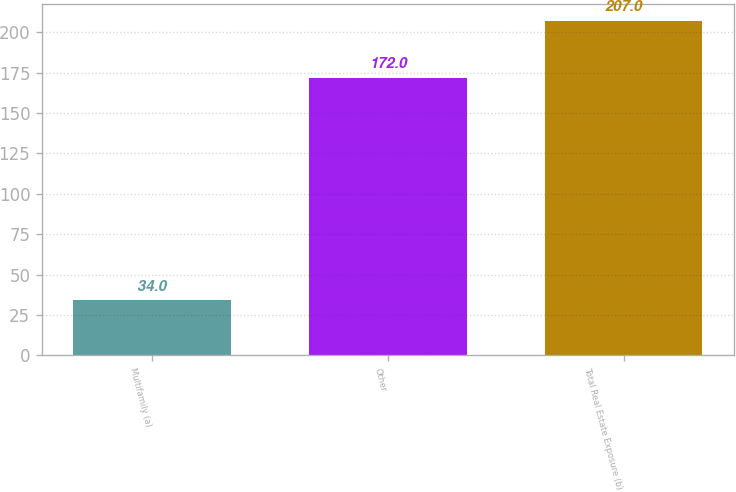Convert chart to OTSL. <chart><loc_0><loc_0><loc_500><loc_500><bar_chart><fcel>Multifamily (a)<fcel>Other<fcel>Total Real Estate Exposure (b)<nl><fcel>34<fcel>172<fcel>207<nl></chart> 